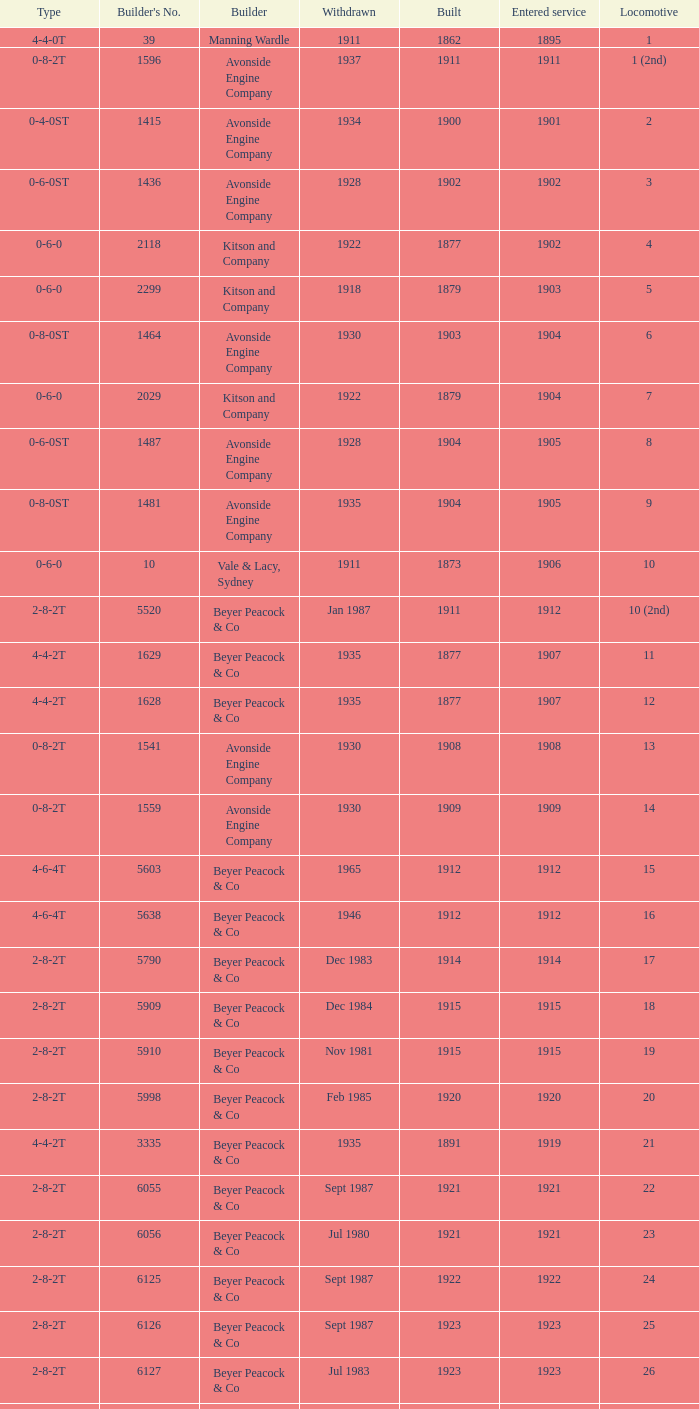Which locomotive had a 2-8-2t type, entered service year prior to 1915, and which was built after 1911? 17.0. 